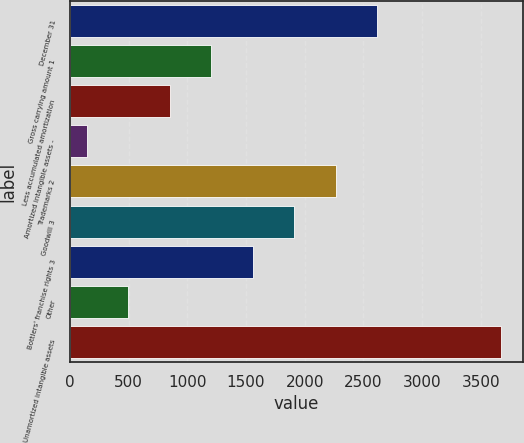Convert chart. <chart><loc_0><loc_0><loc_500><loc_500><bar_chart><fcel>December 31<fcel>Gross carrying amount 1<fcel>Less accumulated amortization<fcel>Amortized intangible assets -<fcel>Trademarks 2<fcel>Goodwill 3<fcel>Bottlers' franchise rights 3<fcel>Other<fcel>Unamortized intangible assets<nl><fcel>2616.3<fcel>1204.7<fcel>851.8<fcel>146<fcel>2263.4<fcel>1910.5<fcel>1557.6<fcel>498.9<fcel>3675<nl></chart> 